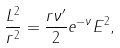<formula> <loc_0><loc_0><loc_500><loc_500>\frac { L ^ { 2 } } { r ^ { 2 } } = \frac { r \nu ^ { \prime } } { 2 } e ^ { - \nu } E ^ { 2 } ,</formula> 